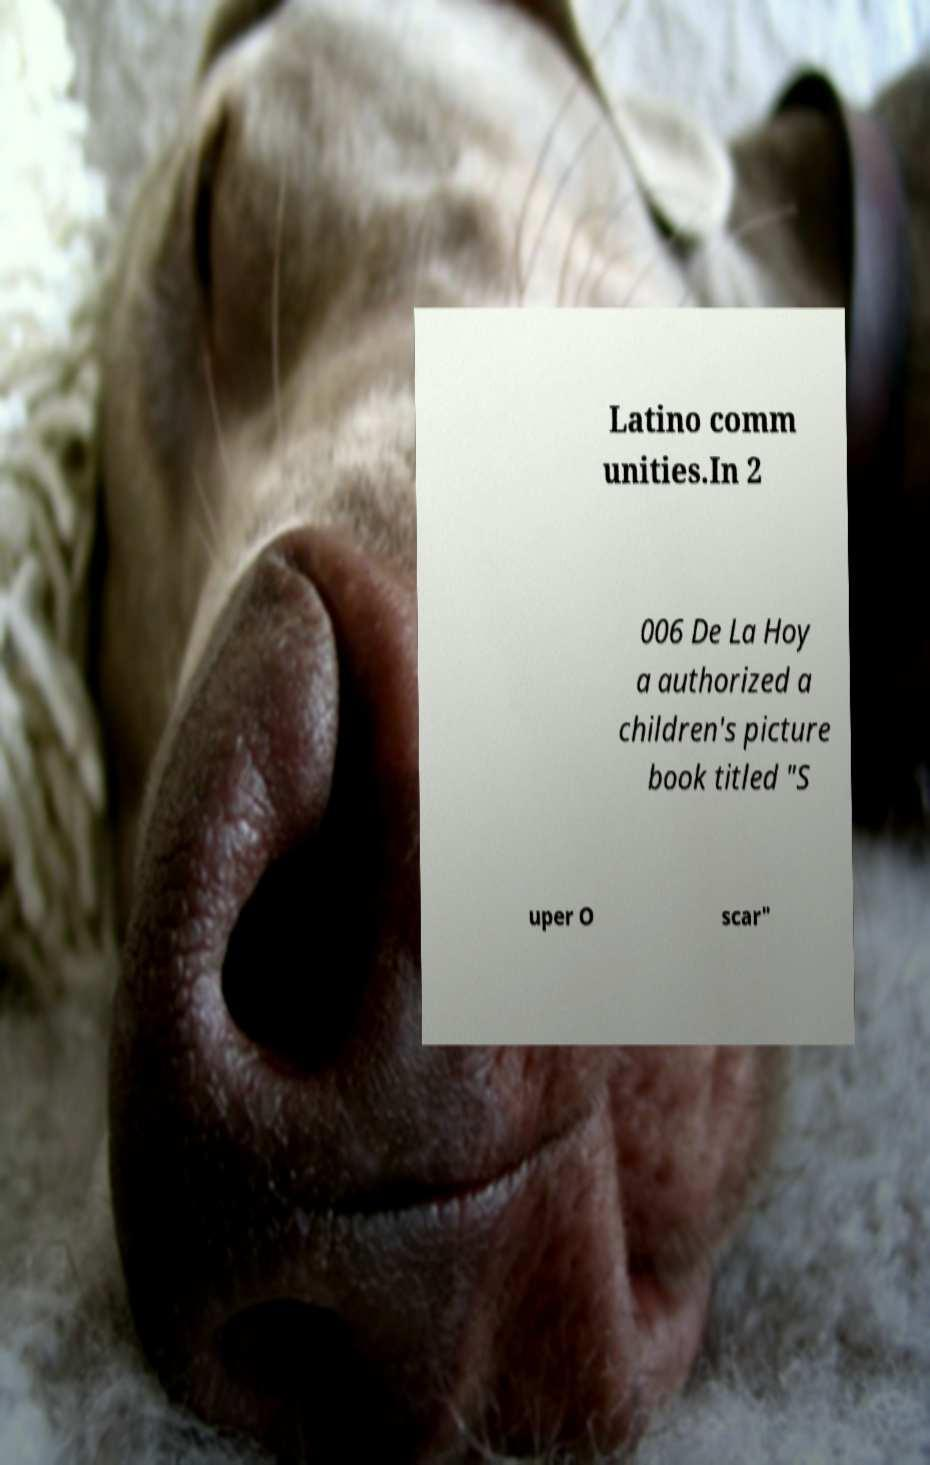There's text embedded in this image that I need extracted. Can you transcribe it verbatim? Latino comm unities.In 2 006 De La Hoy a authorized a children's picture book titled "S uper O scar" 